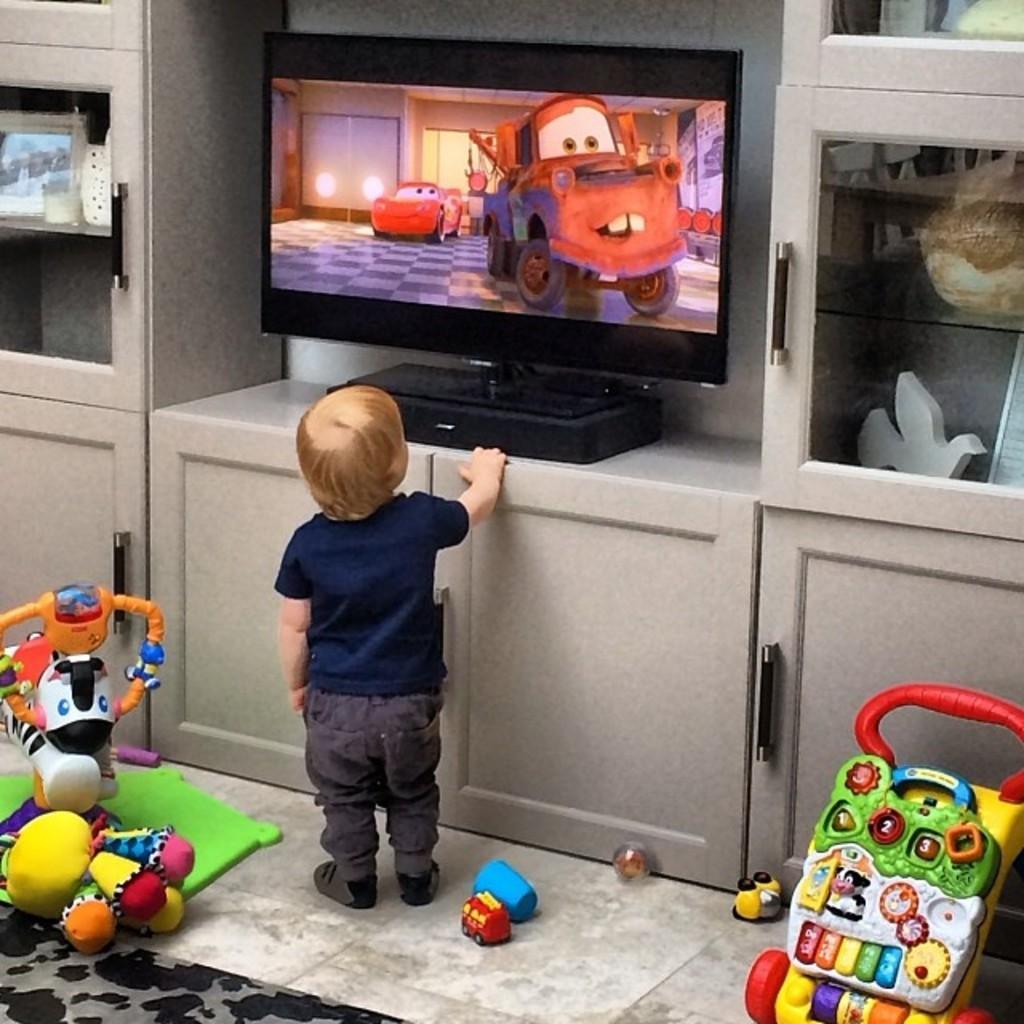Can you describe this image briefly? In this image we can see a kid is standing at the doors of a table, TV on the table, objects and photo frame on the racks in the cupboards, toys and carpet on the floor and objects. 